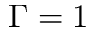Convert formula to latex. <formula><loc_0><loc_0><loc_500><loc_500>\Gamma = 1</formula> 